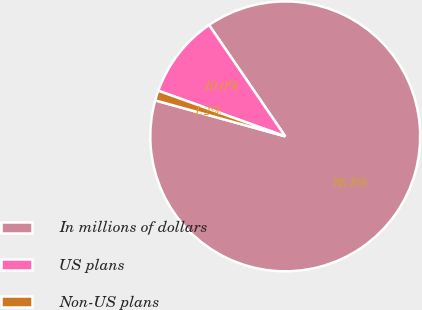<chart> <loc_0><loc_0><loc_500><loc_500><pie_chart><fcel>In millions of dollars<fcel>US plans<fcel>Non-US plans<nl><fcel>88.85%<fcel>9.96%<fcel>1.19%<nl></chart> 